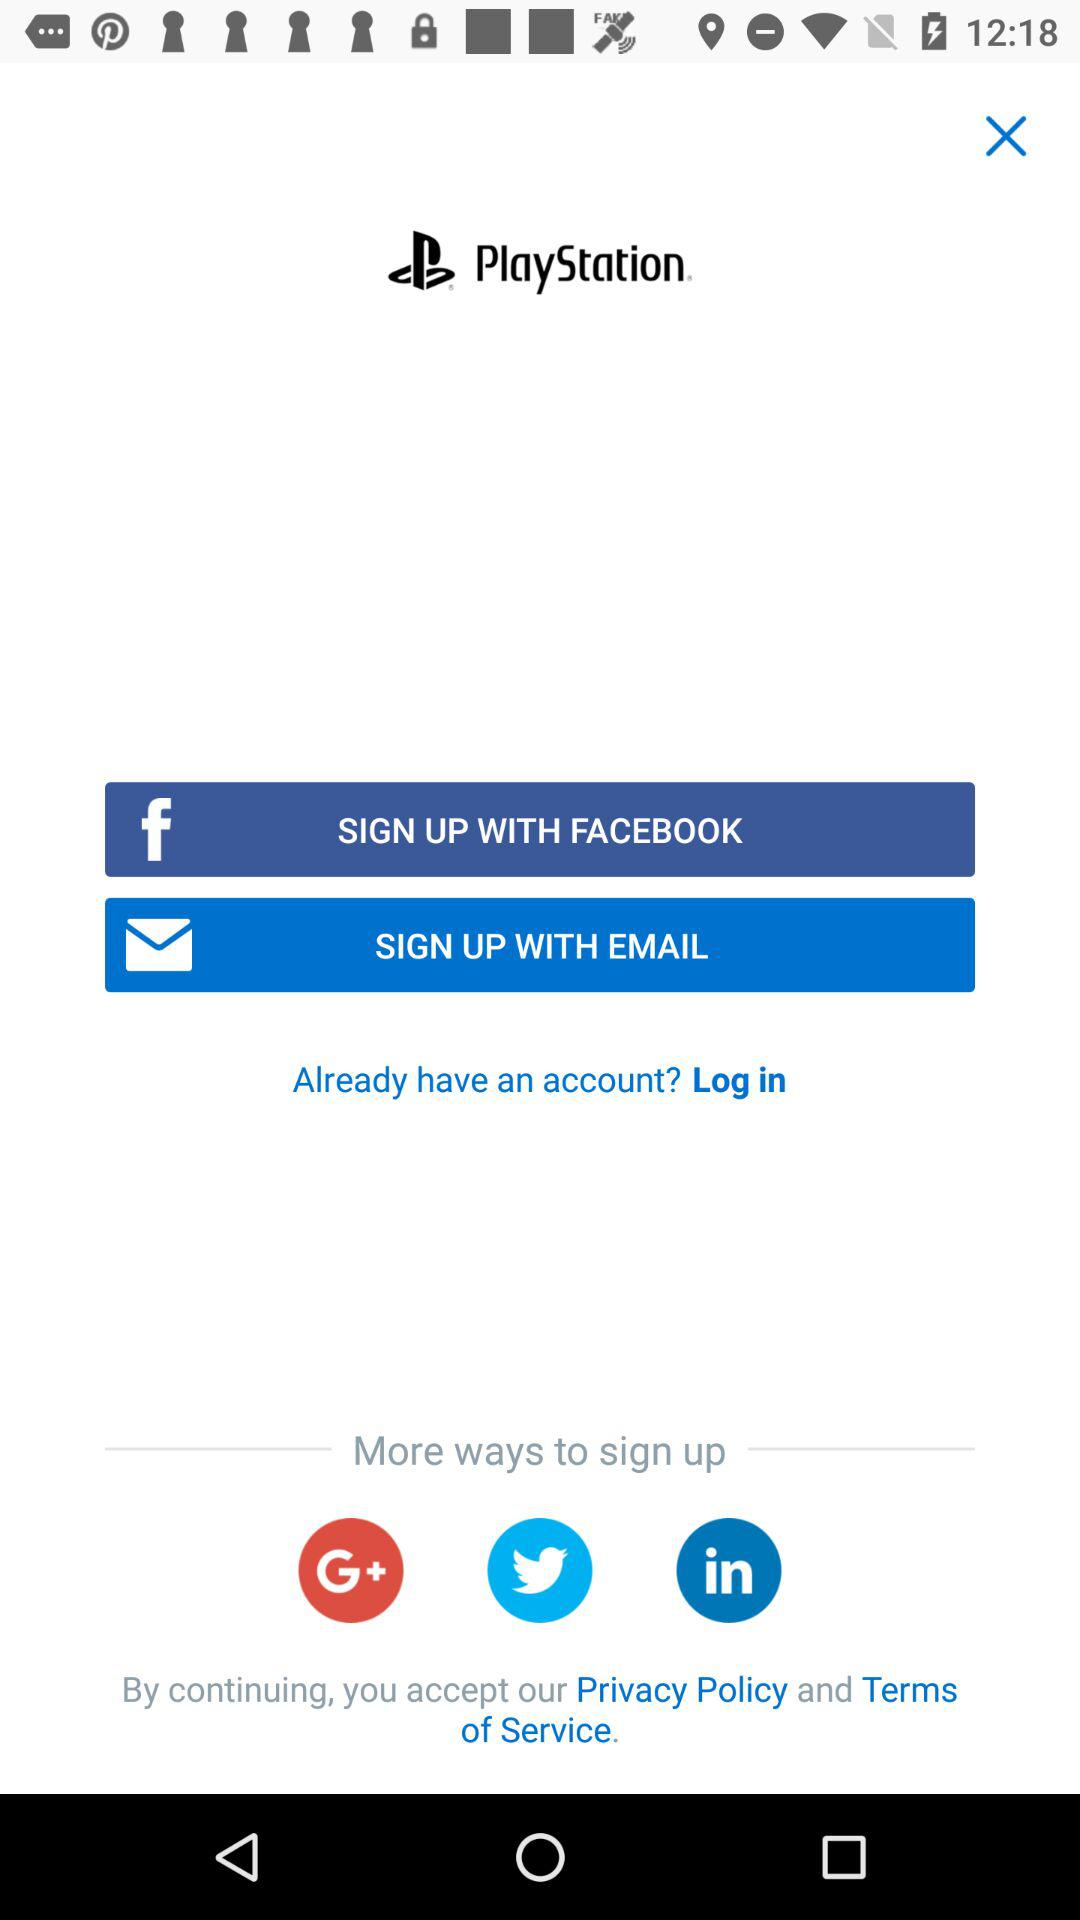What is the application name? The application name is "PlayStation". 